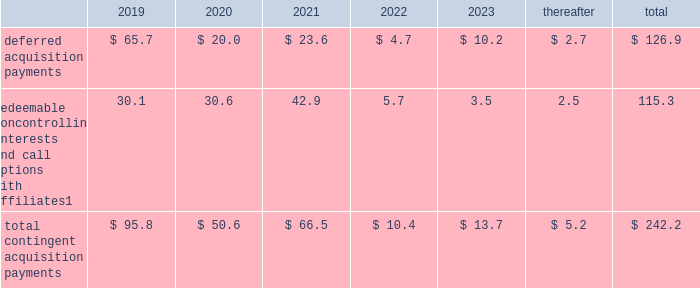Notes to consolidated financial statements 2013 ( continued ) ( amounts in millions , except per share amounts ) guarantees we have guaranteed certain obligations of our subsidiaries relating principally to operating leases and uncommitted lines of credit of certain subsidiaries .
As of december 31 , 2018 and 2017 , the amount of parent company guarantees on lease obligations was $ 824.5 and $ 829.2 , respectively , the amount of parent company guarantees primarily relating to uncommitted lines of credit was $ 349.1 and $ 308.8 , respectively , and the amount of parent company guarantees related to daylight overdrafts , primarily utilized to manage intra-day overdrafts due to timing of transactions under cash pooling arrangements without resulting in incremental borrowings , was $ 207.8 and $ 182.2 , respectively .
In the event of non-payment by the applicable subsidiary of the obligations covered by a guarantee , we would be obligated to pay the amounts covered by that guarantee .
As of december 31 , 2018 , there were no material assets pledged as security for such parent company guarantees .
Contingent acquisition obligations the table details the estimated future contingent acquisition obligations payable in cash as of december 31 .
1 we have entered into certain acquisitions that contain both redeemable noncontrolling interests and call options with similar terms and conditions .
The estimated amounts listed would be paid in the event of exercise at the earliest exercise date .
We have certain redeemable noncontrolling interests that are exercisable at the discretion of the noncontrolling equity owners as of december 31 , 2018 .
These estimated payments of $ 24.9 are included within the total payments expected to be made in 2019 , and will continue to be carried forward into 2020 or beyond until exercised or expired .
Redeemable noncontrolling interests are included in the table at current exercise price payable in cash , not at applicable redemption value , in accordance with the authoritative guidance for classification and measurement of redeemable securities .
The majority of these payments are contingent upon achieving projected operating performance targets and satisfying other conditions specified in the related agreements and are subject to revision in accordance with the terms of the respective agreements .
See note 5 for further information relating to the payment structure of our acquisitions .
Legal matters we are involved in various legal proceedings , and subject to investigations , inspections , audits , inquiries and similar actions by governmental authorities arising in the normal course of business .
The types of allegations that arise in connection with such legal proceedings vary in nature , but can include claims related to contract , employment , tax and intellectual property matters .
We evaluate all cases each reporting period and record liabilities for losses from legal proceedings when we determine that it is probable that the outcome in a legal proceeding will be unfavorable and the amount , or potential range , of loss can be reasonably estimated .
In certain cases , we cannot reasonably estimate the potential loss because , for example , the litigation is in its early stages .
While any outcome related to litigation or such governmental proceedings in which we are involved cannot be predicted with certainty , management believes that the outcome of these matters , individually and in the aggregate , will not have a material adverse effect on our financial condition , results of operations or cash flows .
As previously disclosed , on april 10 , 2015 , a federal judge in brazil authorized the search of the records of an agency 2019s offices in s e3o paulo and brasilia , in connection with an ongoing investigation by brazilian authorities involving payments potentially connected to local government contracts .
The company had previously investigated the matter and taken a number of remedial and disciplinary actions .
The company has been in the process of concluding a settlement related to these matters with government agencies , and that settlement was fully executed in april 2018 .
The company has previously provided for such settlement in its consolidated financial statements. .
What percentage of the total deferred acquisition payments were made in 2019? 
Computations: ((65.7 / 126.9) * 100)
Answer: 51.77305. 